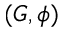Convert formula to latex. <formula><loc_0><loc_0><loc_500><loc_500>( G , \phi )</formula> 